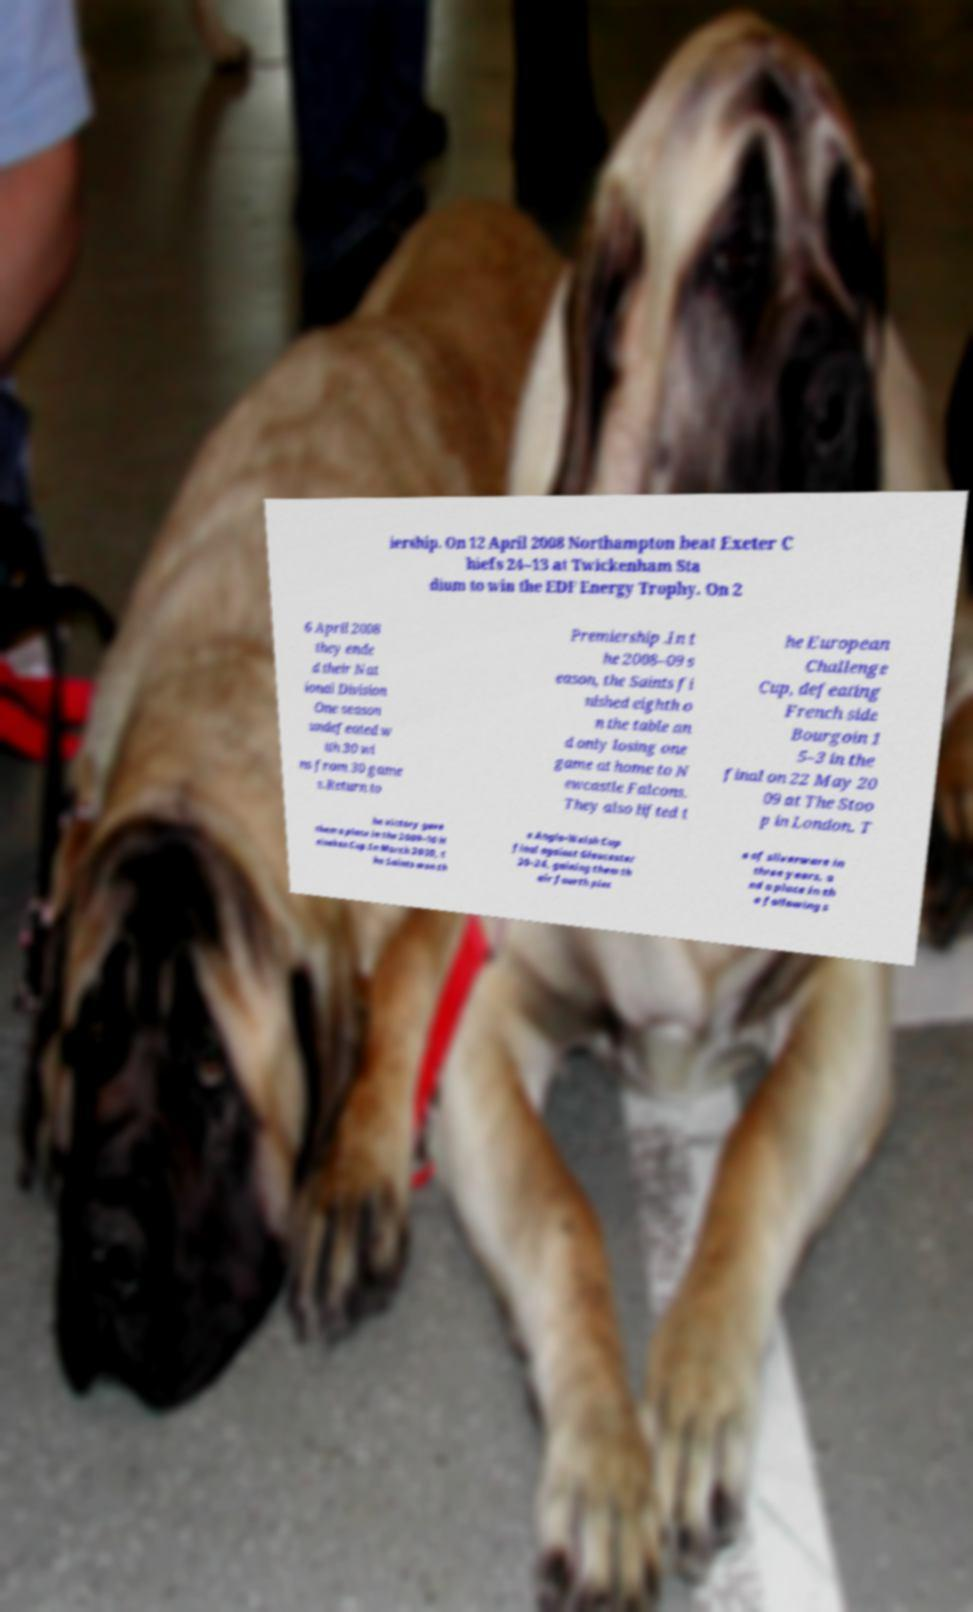Please read and relay the text visible in this image. What does it say? iership. On 12 April 2008 Northampton beat Exeter C hiefs 24–13 at Twickenham Sta dium to win the EDF Energy Trophy. On 2 6 April 2008 they ende d their Nat ional Division One season undefeated w ith 30 wi ns from 30 game s.Return to Premiership .In t he 2008–09 s eason, the Saints fi nished eighth o n the table an d only losing one game at home to N ewcastle Falcons. They also lifted t he European Challenge Cup, defeating French side Bourgoin 1 5–3 in the final on 22 May 20 09 at The Stoo p in London. T he victory gave them a place in the 2009–10 H eineken Cup.In March 2010, t he Saints won th e Anglo-Welsh Cup final against Gloucester 30–24, gaining them th eir fourth piec e of silverware in three years, a nd a place in th e following s 